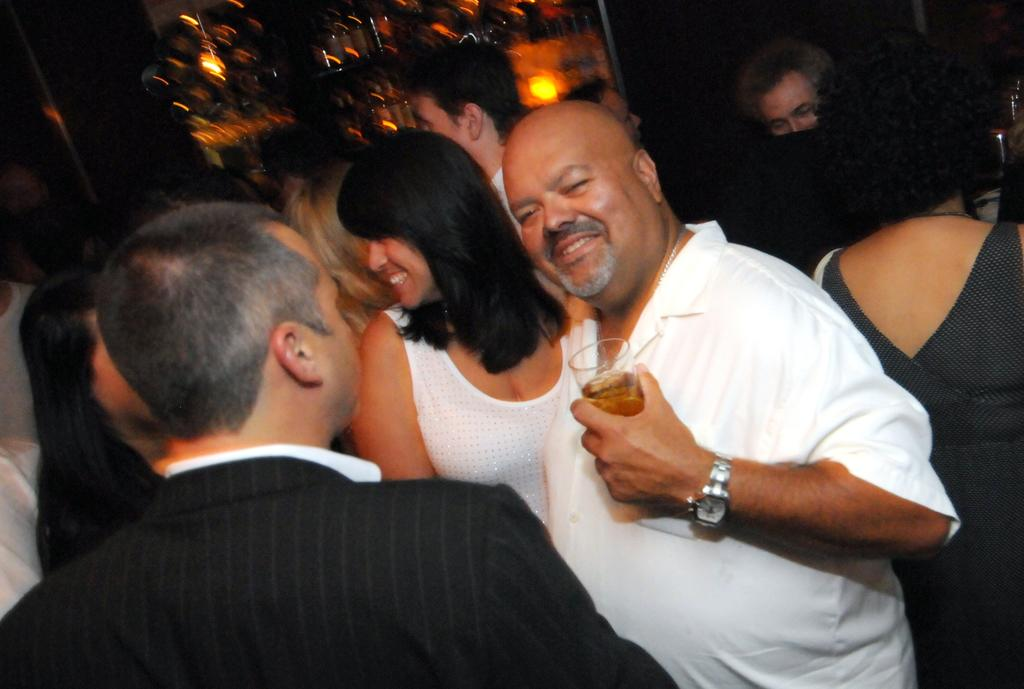How many people are in the image? There are people in the image. Can you describe the man in the center of the image? A man is standing in the center of the image, and he is holding a wine glass. What can be seen in the background of the image? There are lights in the background of the image. How many legs does the beast have in the image? There is no beast present in the image. What color is the ladybug on the man's shoulder in the image? There is no ladybug present on the man's shoulder in the image. 